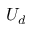Convert formula to latex. <formula><loc_0><loc_0><loc_500><loc_500>U _ { d }</formula> 